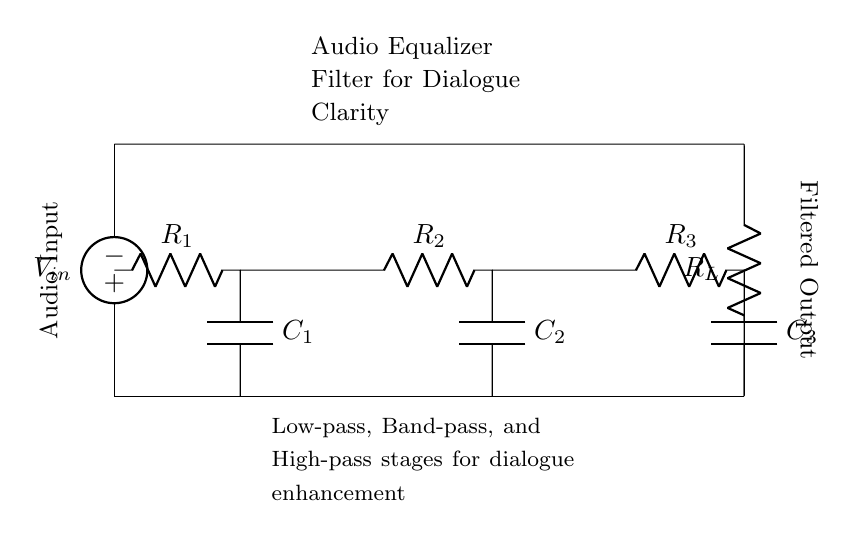What is the input voltage of the circuit? The input voltage is represented by the voltage source labeled V in the circuit diagram, indicating the source of power for the filter.
Answer: V What components are used in the circuit? The circuit includes resistors R1, R2, R3, and R_L, as well as capacitors C1, C2, C3, and an input voltage source V.
Answer: Resistors and capacitors What type of filter is this circuit designed to be? The circuit is designed as an audio equalizer filter specifically meant to enhance dialogue clarity, indicated by the labeling and arrangement of components for frequency response.
Answer: Audio equalizer filter How many resistors are in the circuit? There are four resistors indicated in the circuit diagram: R1, R2, R3, and R_L, which contribute to the overall impedance characteristics.
Answer: Four What purpose do capacitors serve in this circuit? Capacitors C1, C2, and C3 are used to form low-pass, band-pass, and high-pass filter stages, which help isolate the dialogue frequencies from other sounds, thereby enhancing clarity.
Answer: Enhance frequency response What is the role of R_L in the circuit? R_L serves as the load resistor, providing an output impedance for the filtered audio signal, allowing it to effectively drive subsequent stages or devices connected to the output.
Answer: Load resistor What filtering stages are included in this circuit? The circuit is designed with low-pass, band-pass, and high-pass stages, as noted in the annotations, which work together to optimize the clarity of dialogue within the audio recordings.
Answer: Three stages 